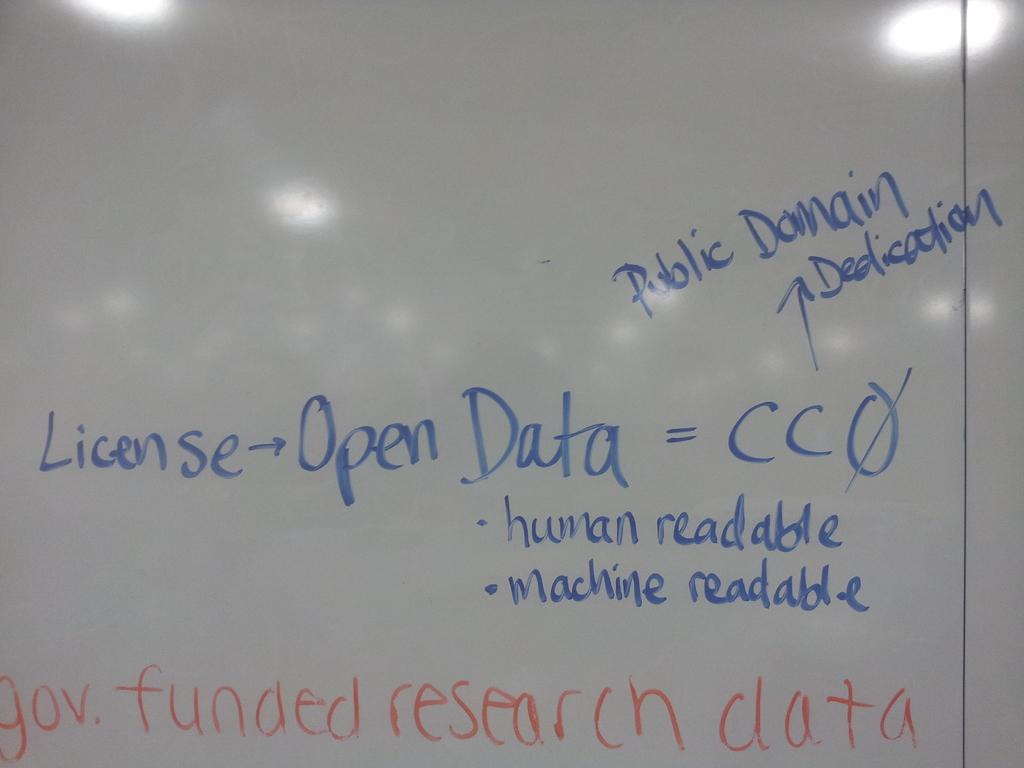<image>
Offer a succinct explanation of the picture presented. Government funded research data requires a license for access but is then both human and machine readable. 